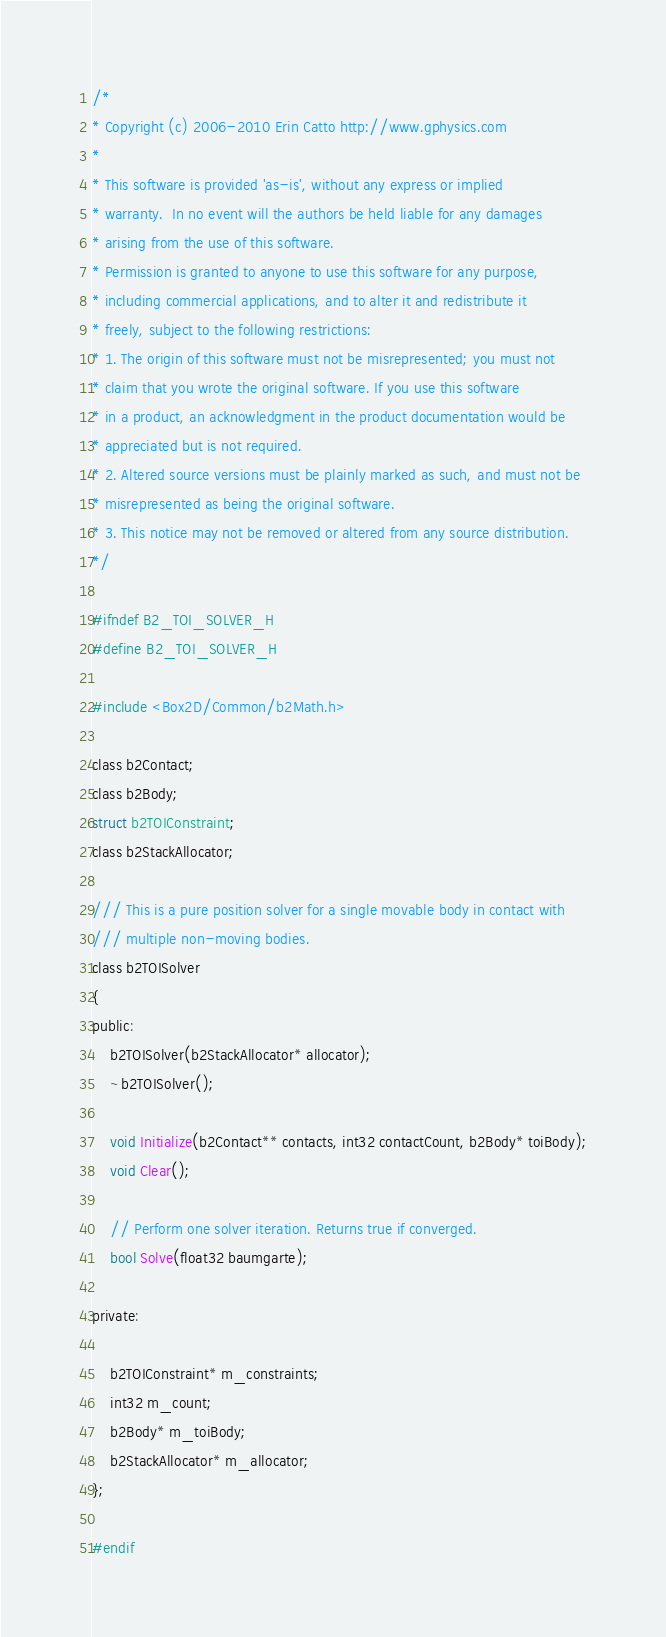Convert code to text. <code><loc_0><loc_0><loc_500><loc_500><_C_>/*
* Copyright (c) 2006-2010 Erin Catto http://www.gphysics.com
*
* This software is provided 'as-is', without any express or implied
* warranty.  In no event will the authors be held liable for any damages
* arising from the use of this software.
* Permission is granted to anyone to use this software for any purpose,
* including commercial applications, and to alter it and redistribute it
* freely, subject to the following restrictions:
* 1. The origin of this software must not be misrepresented; you must not
* claim that you wrote the original software. If you use this software
* in a product, an acknowledgment in the product documentation would be
* appreciated but is not required.
* 2. Altered source versions must be plainly marked as such, and must not be
* misrepresented as being the original software.
* 3. This notice may not be removed or altered from any source distribution.
*/

#ifndef B2_TOI_SOLVER_H
#define B2_TOI_SOLVER_H

#include <Box2D/Common/b2Math.h>

class b2Contact;
class b2Body;
struct b2TOIConstraint;
class b2StackAllocator;

/// This is a pure position solver for a single movable body in contact with
/// multiple non-moving bodies.
class b2TOISolver
{
public:
	b2TOISolver(b2StackAllocator* allocator);
	~b2TOISolver();

	void Initialize(b2Contact** contacts, int32 contactCount, b2Body* toiBody);
	void Clear();

	// Perform one solver iteration. Returns true if converged.
	bool Solve(float32 baumgarte);

private:

	b2TOIConstraint* m_constraints;
	int32 m_count;
	b2Body* m_toiBody;
	b2StackAllocator* m_allocator;
};

#endif

</code> 